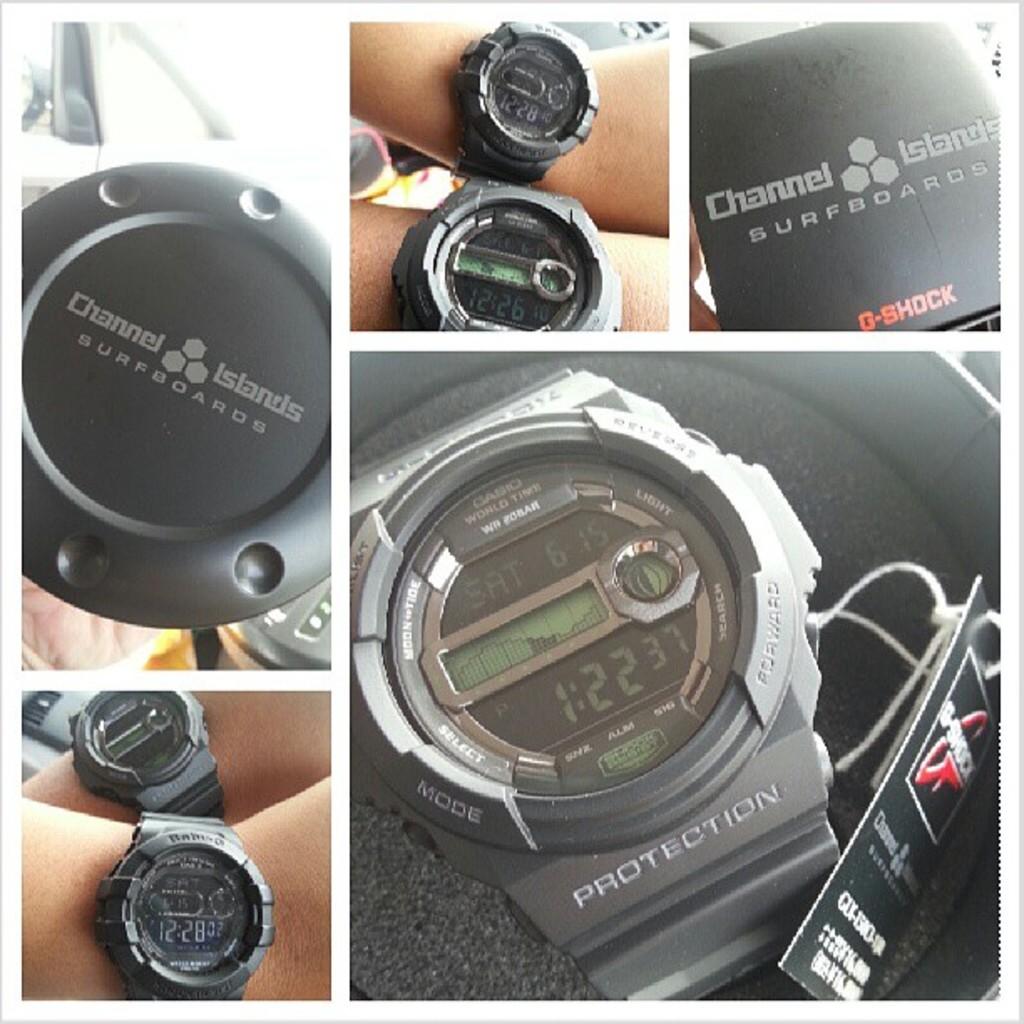What is the brand of this watch?
Your answer should be very brief. Casio. 